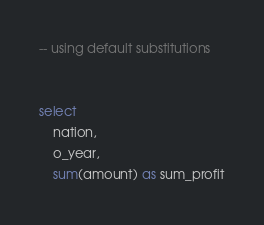<code> <loc_0><loc_0><loc_500><loc_500><_SQL_>-- using default substitutions


select
    nation,
    o_year,
    sum(amount) as sum_profit</code> 